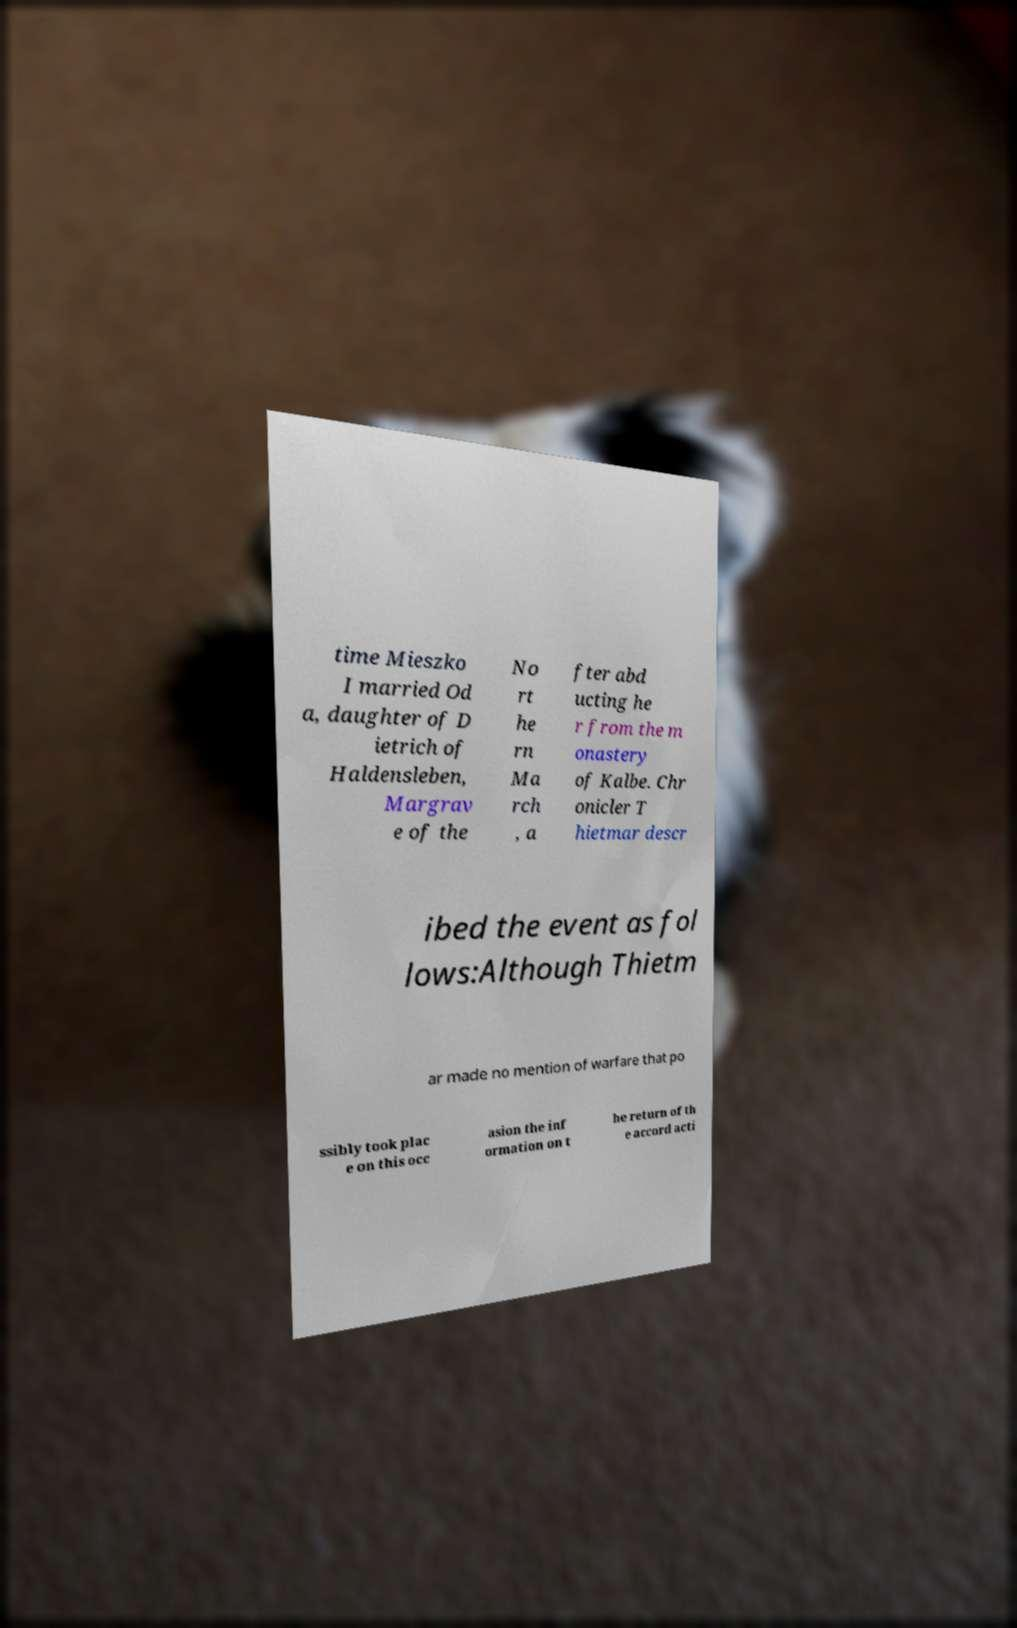Can you read and provide the text displayed in the image?This photo seems to have some interesting text. Can you extract and type it out for me? time Mieszko I married Od a, daughter of D ietrich of Haldensleben, Margrav e of the No rt he rn Ma rch , a fter abd ucting he r from the m onastery of Kalbe. Chr onicler T hietmar descr ibed the event as fol lows:Although Thietm ar made no mention of warfare that po ssibly took plac e on this occ asion the inf ormation on t he return of th e accord acti 